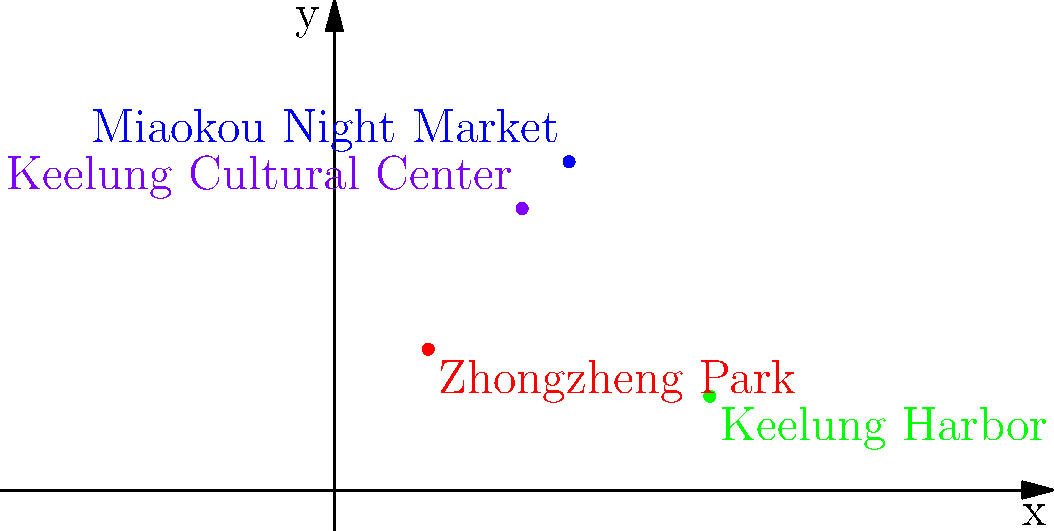As a tour guide in Keelung City, you're explaining the locations of popular attractions using a coordinate system. Given the map above, which attraction is located at the coordinates (8,2)? To answer this question, we need to analyze the 2D map of Keelung City and identify the attraction located at the coordinates (8,2). Let's break it down step-by-step:

1. The map shows four attractions plotted on a coordinate system:
   - Zhongzheng Park (red dot)
   - Miaokou Night Market (blue dot)
   - Keelung Harbor (green dot)
   - Keelung Cultural Center (purple dot)

2. We need to find the point with coordinates (8,2):
   - The x-coordinate is 8 (move 8 units to the right on the x-axis)
   - The y-coordinate is 2 (move 2 units up on the y-axis)

3. Looking at the map, we can see that the green dot is located at (8,2).

4. The green dot is labeled "Keelung Harbor".

Therefore, the attraction located at coordinates (8,2) is Keelung Harbor.
Answer: Keelung Harbor 